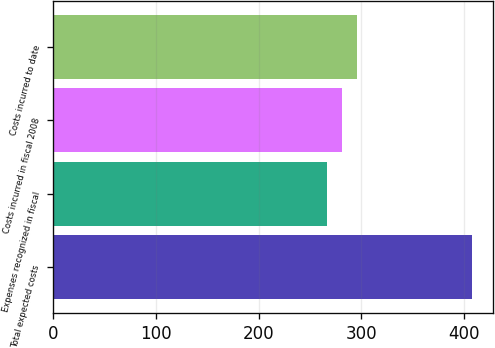Convert chart. <chart><loc_0><loc_0><loc_500><loc_500><bar_chart><fcel>Total expected costs<fcel>Expenses recognized in fiscal<fcel>Costs incurred in fiscal 2008<fcel>Costs incurred to date<nl><fcel>407.8<fcel>266.9<fcel>281.7<fcel>295.79<nl></chart> 